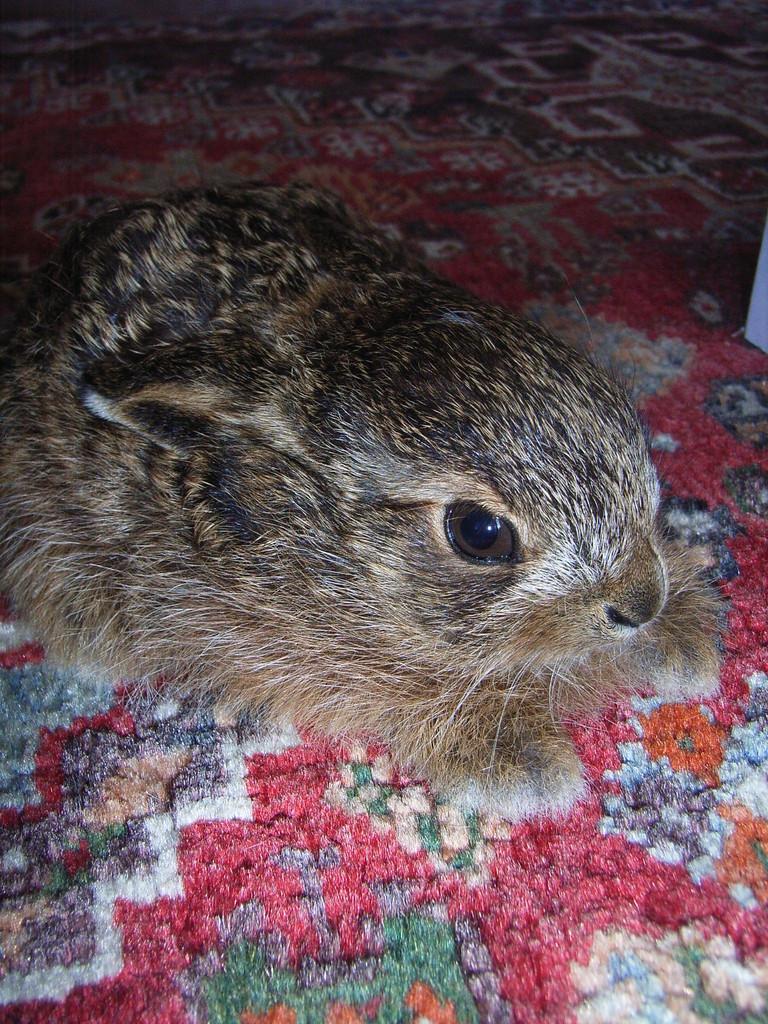In one or two sentences, can you explain what this image depicts? In this image, I can see a rabbit on a carpet. 